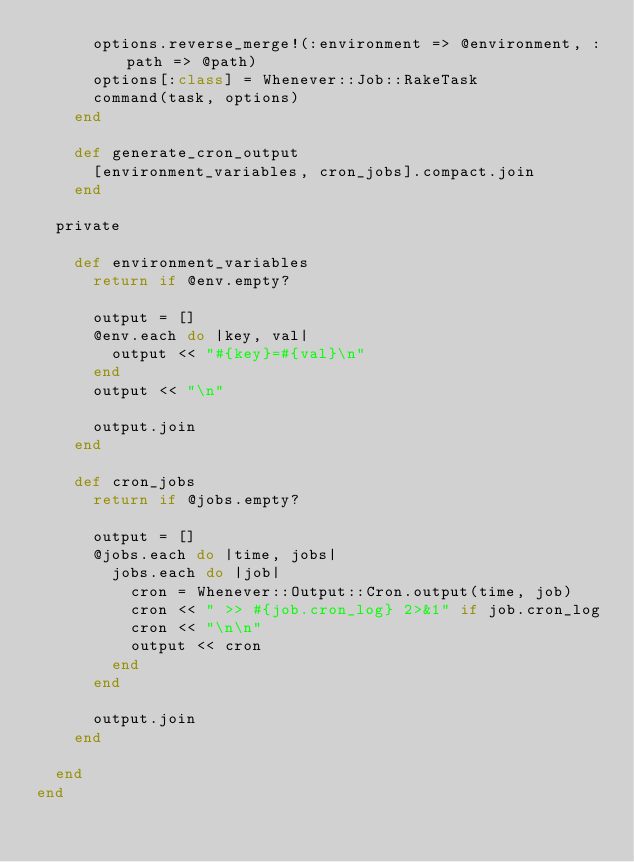<code> <loc_0><loc_0><loc_500><loc_500><_Ruby_>      options.reverse_merge!(:environment => @environment, :path => @path)
      options[:class] = Whenever::Job::RakeTask
      command(task, options)
    end
  
    def generate_cron_output
      [environment_variables, cron_jobs].compact.join
    end
    
  private
  
    def environment_variables
      return if @env.empty?
      
      output = []
      @env.each do |key, val|
        output << "#{key}=#{val}\n"
      end
      output << "\n"
      
      output.join
    end
    
    def cron_jobs
      return if @jobs.empty?
      
      output = []
      @jobs.each do |time, jobs|
        jobs.each do |job|
          cron = Whenever::Output::Cron.output(time, job)
          cron << " >> #{job.cron_log} 2>&1" if job.cron_log 
          cron << "\n\n"
          output << cron
        end
      end
      
      output.join
    end
    
  end
end</code> 